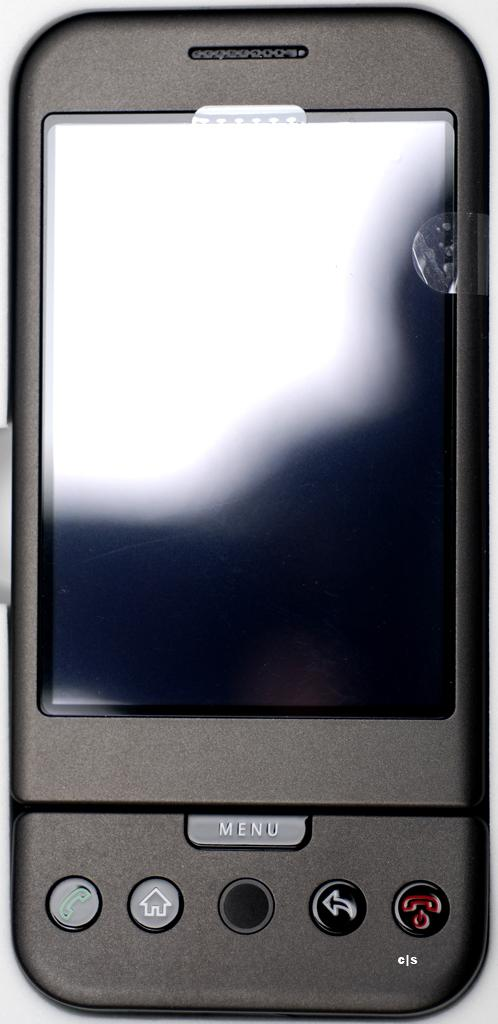What is the color of the electronic gadget in the image? The electronic gadget is black in color. Where are the buttons located on the gadget? The buttons are on the bottom side of the gadget. What word is written on the side of the gadget? There is no word written on the side of the gadget in the image. Can you tell me if the son of the person who owns the gadget is present in the image? There is no information about a son or any person in the image, so it cannot be determined if the son is present. 